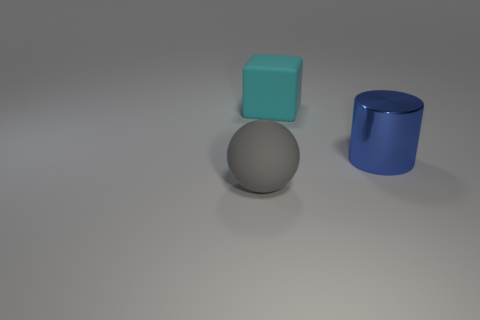Is there anything else that is made of the same material as the blue thing?
Keep it short and to the point. No. There is a thing that is both in front of the cyan cube and right of the big gray ball; what color is it?
Offer a very short reply. Blue. How many things are either matte objects that are to the right of the large gray rubber ball or objects in front of the large cube?
Provide a succinct answer. 3. What is the color of the big rubber thing that is on the left side of the large rubber object that is behind the rubber thing that is in front of the big cylinder?
Give a very brief answer. Gray. Is there another big shiny thing of the same shape as the large blue object?
Your answer should be compact. No. How many large matte cubes are there?
Offer a terse response. 1. There is a cyan rubber object; what shape is it?
Give a very brief answer. Cube. What number of rubber balls have the same size as the cube?
Ensure brevity in your answer.  1. Is the big gray thing the same shape as the blue metal thing?
Your response must be concise. No. What color is the thing that is left of the matte thing right of the gray object?
Provide a succinct answer. Gray. 